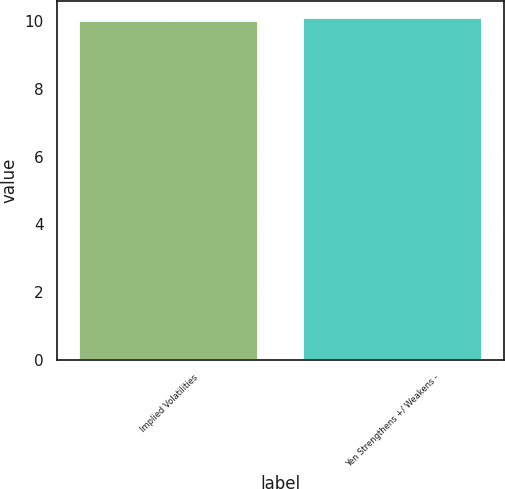Convert chart. <chart><loc_0><loc_0><loc_500><loc_500><bar_chart><fcel>Implied Volatilities<fcel>Yen Strengthens +/ Weakens -<nl><fcel>10<fcel>10.1<nl></chart> 